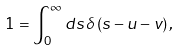<formula> <loc_0><loc_0><loc_500><loc_500>1 = \int _ { 0 } ^ { \infty } d s \, \delta \left ( s - u - v \right ) ,</formula> 